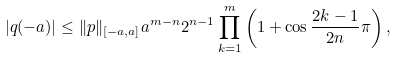Convert formula to latex. <formula><loc_0><loc_0><loc_500><loc_500>| q ( - a ) | \leq \| p \| _ { [ - a , a ] } a ^ { m - n } 2 ^ { n - 1 } \prod _ { k = 1 } ^ { m } \left ( 1 + \cos \frac { 2 k - 1 } { 2 n } \pi \right ) ,</formula> 